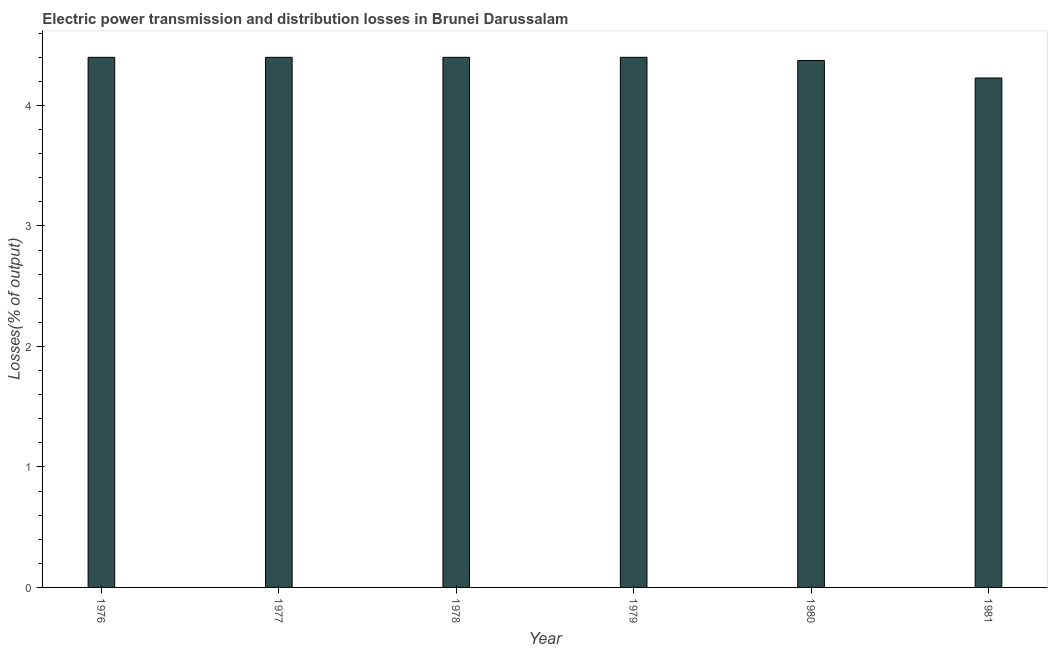Does the graph contain any zero values?
Your answer should be compact. No. Does the graph contain grids?
Offer a very short reply. No. What is the title of the graph?
Offer a terse response. Electric power transmission and distribution losses in Brunei Darussalam. What is the label or title of the X-axis?
Offer a terse response. Year. What is the label or title of the Y-axis?
Your answer should be compact. Losses(% of output). What is the electric power transmission and distribution losses in 1979?
Ensure brevity in your answer.  4.4. Across all years, what is the maximum electric power transmission and distribution losses?
Provide a succinct answer. 4.4. Across all years, what is the minimum electric power transmission and distribution losses?
Your response must be concise. 4.23. In which year was the electric power transmission and distribution losses maximum?
Your response must be concise. 1976. What is the sum of the electric power transmission and distribution losses?
Provide a succinct answer. 26.2. What is the difference between the electric power transmission and distribution losses in 1976 and 1979?
Give a very brief answer. 0. What is the average electric power transmission and distribution losses per year?
Provide a short and direct response. 4.37. Do a majority of the years between 1976 and 1979 (inclusive) have electric power transmission and distribution losses greater than 1 %?
Give a very brief answer. Yes. What is the ratio of the electric power transmission and distribution losses in 1978 to that in 1981?
Ensure brevity in your answer.  1.04. Is the electric power transmission and distribution losses in 1977 less than that in 1979?
Give a very brief answer. No. What is the difference between the highest and the lowest electric power transmission and distribution losses?
Ensure brevity in your answer.  0.17. In how many years, is the electric power transmission and distribution losses greater than the average electric power transmission and distribution losses taken over all years?
Your answer should be compact. 5. How many bars are there?
Ensure brevity in your answer.  6. Are all the bars in the graph horizontal?
Keep it short and to the point. No. How many years are there in the graph?
Keep it short and to the point. 6. What is the Losses(% of output) in 1976?
Provide a short and direct response. 4.4. What is the Losses(% of output) in 1980?
Keep it short and to the point. 4.37. What is the Losses(% of output) of 1981?
Offer a terse response. 4.23. What is the difference between the Losses(% of output) in 1976 and 1978?
Keep it short and to the point. 0. What is the difference between the Losses(% of output) in 1976 and 1979?
Your answer should be very brief. 0. What is the difference between the Losses(% of output) in 1976 and 1980?
Keep it short and to the point. 0.03. What is the difference between the Losses(% of output) in 1976 and 1981?
Ensure brevity in your answer.  0.17. What is the difference between the Losses(% of output) in 1977 and 1979?
Make the answer very short. 0. What is the difference between the Losses(% of output) in 1977 and 1980?
Give a very brief answer. 0.03. What is the difference between the Losses(% of output) in 1977 and 1981?
Ensure brevity in your answer.  0.17. What is the difference between the Losses(% of output) in 1978 and 1979?
Make the answer very short. 0. What is the difference between the Losses(% of output) in 1978 and 1980?
Provide a short and direct response. 0.03. What is the difference between the Losses(% of output) in 1978 and 1981?
Ensure brevity in your answer.  0.17. What is the difference between the Losses(% of output) in 1979 and 1980?
Offer a very short reply. 0.03. What is the difference between the Losses(% of output) in 1979 and 1981?
Provide a short and direct response. 0.17. What is the difference between the Losses(% of output) in 1980 and 1981?
Make the answer very short. 0.14. What is the ratio of the Losses(% of output) in 1976 to that in 1977?
Provide a short and direct response. 1. What is the ratio of the Losses(% of output) in 1976 to that in 1979?
Your response must be concise. 1. What is the ratio of the Losses(% of output) in 1976 to that in 1980?
Offer a terse response. 1.01. What is the ratio of the Losses(% of output) in 1976 to that in 1981?
Ensure brevity in your answer.  1.04. What is the ratio of the Losses(% of output) in 1977 to that in 1978?
Your answer should be very brief. 1. What is the ratio of the Losses(% of output) in 1977 to that in 1979?
Your answer should be compact. 1. What is the ratio of the Losses(% of output) in 1977 to that in 1981?
Your answer should be very brief. 1.04. What is the ratio of the Losses(% of output) in 1978 to that in 1979?
Provide a succinct answer. 1. What is the ratio of the Losses(% of output) in 1978 to that in 1980?
Your answer should be compact. 1.01. What is the ratio of the Losses(% of output) in 1978 to that in 1981?
Give a very brief answer. 1.04. What is the ratio of the Losses(% of output) in 1979 to that in 1980?
Make the answer very short. 1.01. What is the ratio of the Losses(% of output) in 1979 to that in 1981?
Ensure brevity in your answer.  1.04. What is the ratio of the Losses(% of output) in 1980 to that in 1981?
Keep it short and to the point. 1.03. 